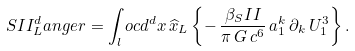Convert formula to latex. <formula><loc_0><loc_0><loc_500><loc_500>S I I _ { L } ^ { d } a n g e r = \int _ { l } o c d ^ { d } x \, \widehat { x } _ { L } \left \{ - \, \frac { \beta _ { S } I I } { \pi \, G \, c ^ { 6 } } \, a _ { 1 } ^ { k } \, \partial _ { k } \, U _ { 1 } ^ { 3 } \right \} .</formula> 